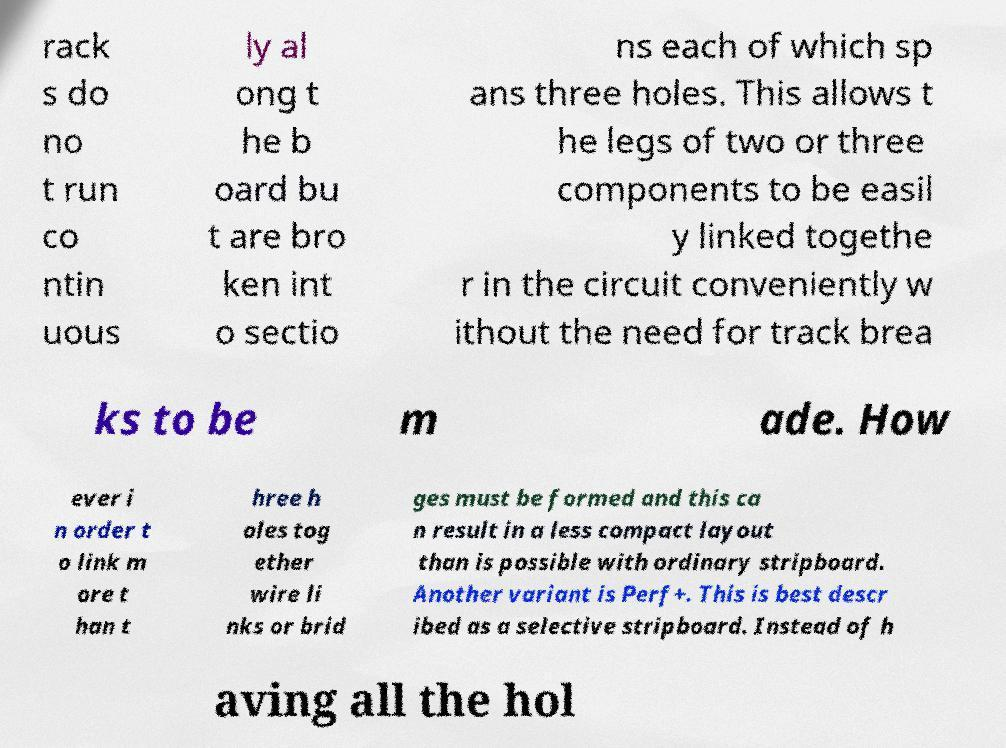I need the written content from this picture converted into text. Can you do that? rack s do no t run co ntin uous ly al ong t he b oard bu t are bro ken int o sectio ns each of which sp ans three holes. This allows t he legs of two or three components to be easil y linked togethe r in the circuit conveniently w ithout the need for track brea ks to be m ade. How ever i n order t o link m ore t han t hree h oles tog ether wire li nks or brid ges must be formed and this ca n result in a less compact layout than is possible with ordinary stripboard. Another variant is Perf+. This is best descr ibed as a selective stripboard. Instead of h aving all the hol 